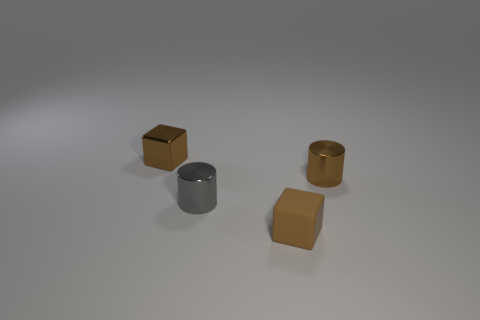Add 2 brown shiny cylinders. How many objects exist? 6 Add 2 small purple spheres. How many small purple spheres exist? 2 Subtract 0 yellow cylinders. How many objects are left? 4 Subtract all brown matte cubes. Subtract all metallic objects. How many objects are left? 0 Add 2 brown objects. How many brown objects are left? 5 